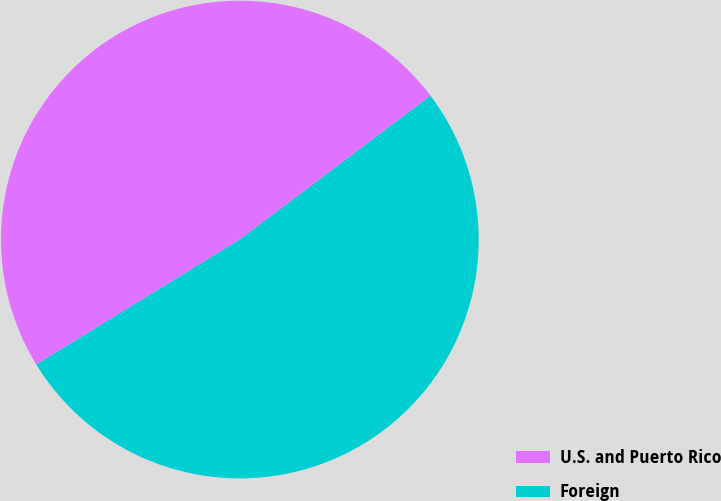Convert chart. <chart><loc_0><loc_0><loc_500><loc_500><pie_chart><fcel>U.S. and Puerto Rico<fcel>Foreign<nl><fcel>48.48%<fcel>51.52%<nl></chart> 